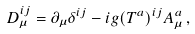<formula> <loc_0><loc_0><loc_500><loc_500>D _ { \mu } ^ { i j } = \partial _ { \mu } \delta ^ { i j } - i g ( T ^ { a } ) ^ { i j } A _ { \mu } ^ { a } \, ,</formula> 